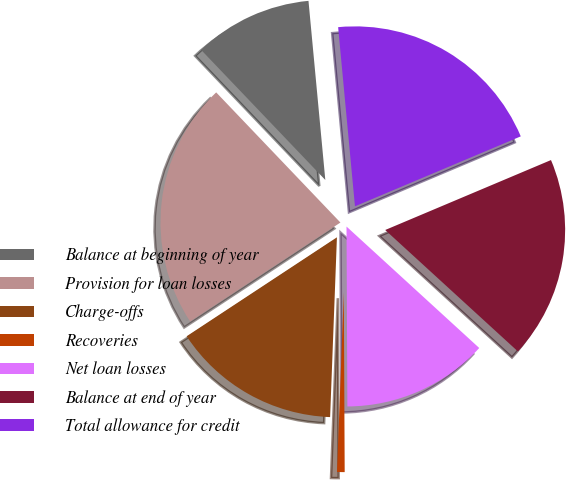Convert chart to OTSL. <chart><loc_0><loc_0><loc_500><loc_500><pie_chart><fcel>Balance at beginning of year<fcel>Provision for loan losses<fcel>Charge-offs<fcel>Recoveries<fcel>Net loan losses<fcel>Balance at end of year<fcel>Total allowance for credit<nl><fcel>10.64%<fcel>22.14%<fcel>15.13%<fcel>0.68%<fcel>13.13%<fcel>18.15%<fcel>20.14%<nl></chart> 